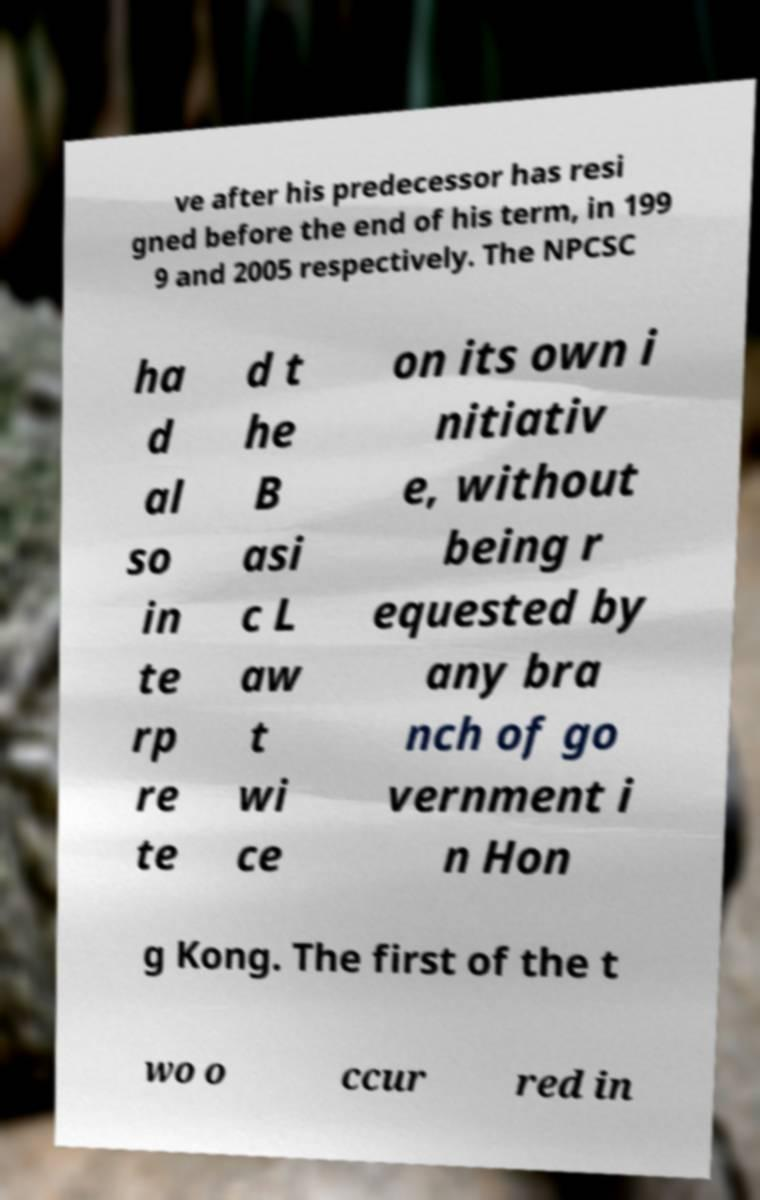Can you accurately transcribe the text from the provided image for me? ve after his predecessor has resi gned before the end of his term, in 199 9 and 2005 respectively. The NPCSC ha d al so in te rp re te d t he B asi c L aw t wi ce on its own i nitiativ e, without being r equested by any bra nch of go vernment i n Hon g Kong. The first of the t wo o ccur red in 